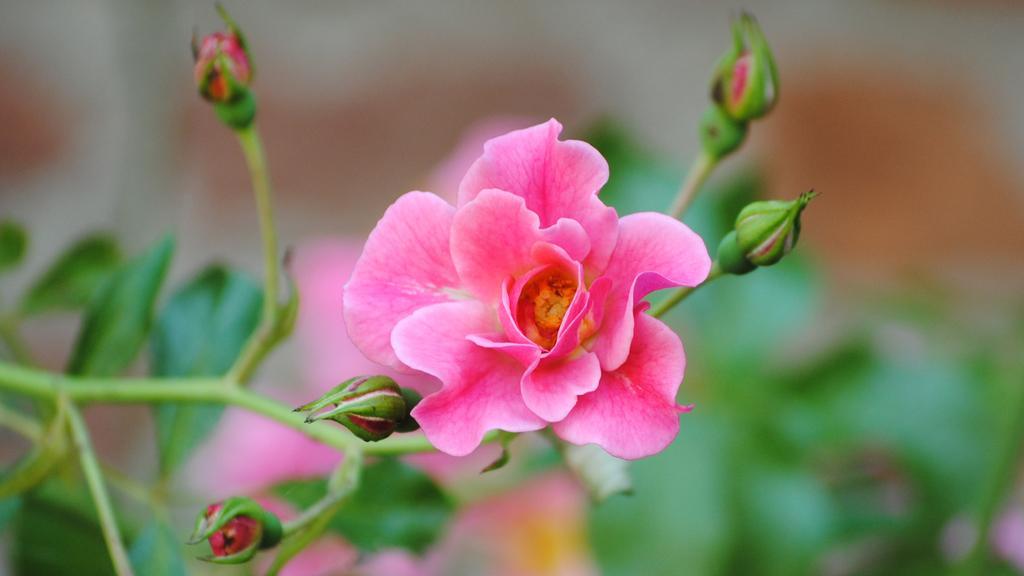Can you describe this image briefly? Here we can see a plant with flowers and buds. In the background the image is blur. 